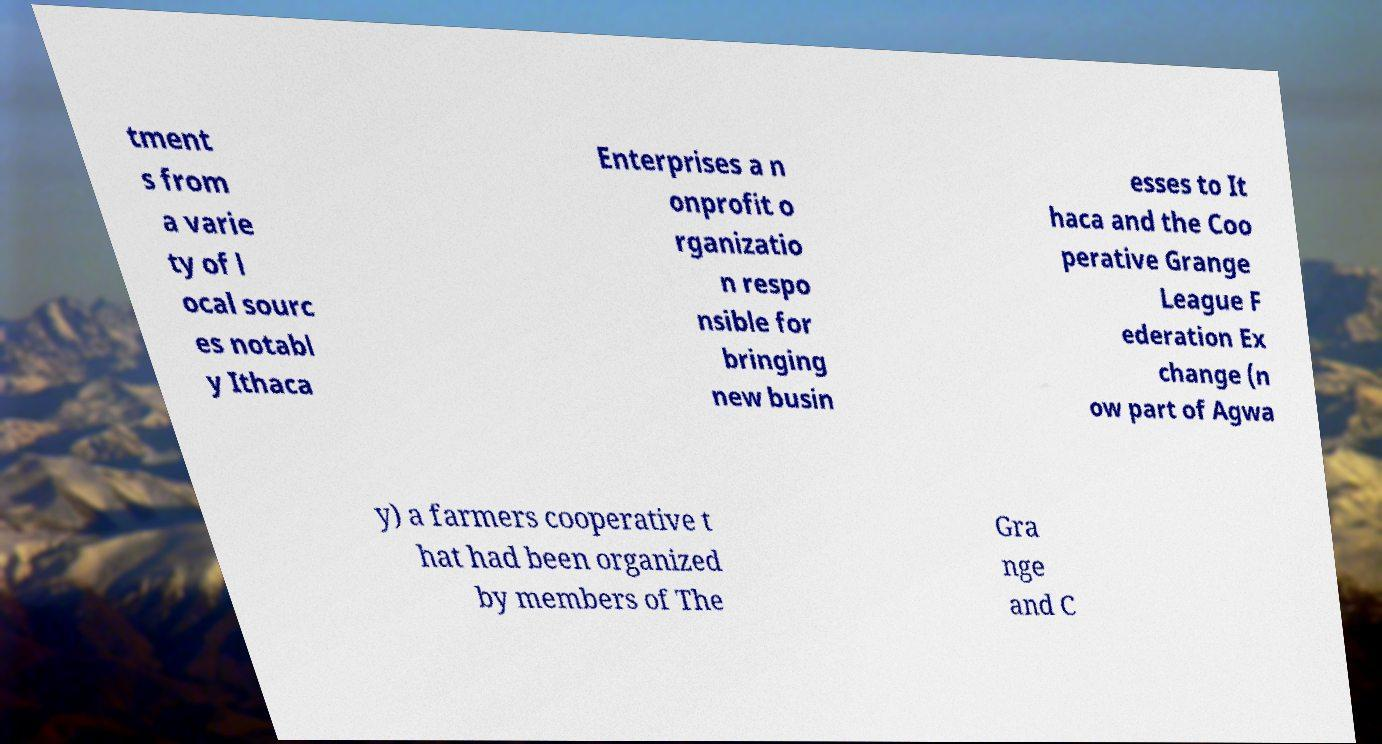Can you read and provide the text displayed in the image?This photo seems to have some interesting text. Can you extract and type it out for me? tment s from a varie ty of l ocal sourc es notabl y Ithaca Enterprises a n onprofit o rganizatio n respo nsible for bringing new busin esses to It haca and the Coo perative Grange League F ederation Ex change (n ow part of Agwa y) a farmers cooperative t hat had been organized by members of The Gra nge and C 